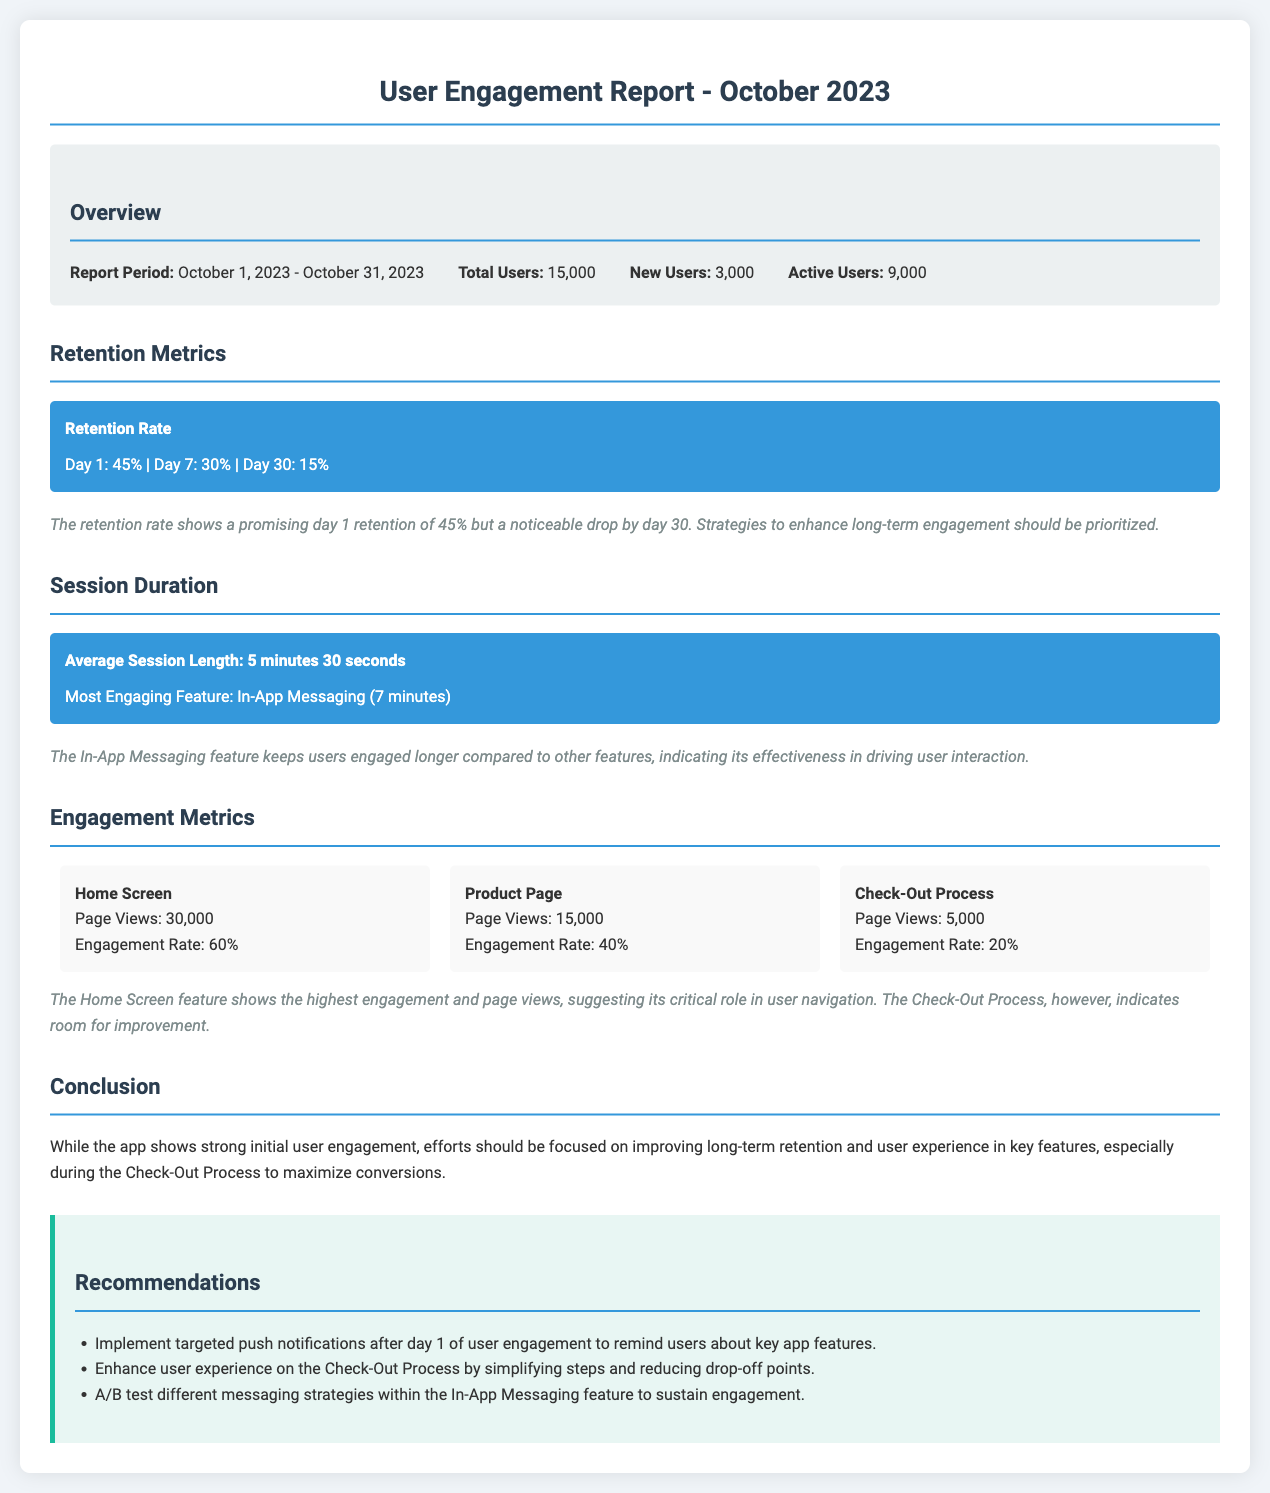What is the report period? The report period is defined at the beginning of the document, covering the span from October 1, 2023, to October 31, 2023.
Answer: October 1, 2023 - October 31, 2023 How many total users were there? The total users are mentioned in the overview section, detailing the specific count.
Answer: 15,000 What was the Day 30 retention rate? The retention metrics section provides the retention rates for specific days, including Day 30.
Answer: 15% What is the average session length? The average session length is specified in the session duration section, indicating user engagement time.
Answer: 5 minutes 30 seconds Which feature has the highest engagement rate? Engagement metrics detail various features and their corresponding engagement rates, highlighting the most engaging one.
Answer: Home Screen How does the Day 1 retention compare to Day 30? A comparison can be drawn from the retention metrics showcasing the drop in user retention from Day 1 to Day 30.
Answer: Significant drop What is a key recommendation regarding the Check-Out Process? The recommendations section emphasizes the importance of optimizing the Check-Out Process, addressing user experience.
Answer: Simplifying steps What was the engagement rate for the Product Page? The engagement metrics provide specific engagement rates for different features, including the Product Page.
Answer: 40% What section provides insights on the feature with most engagement? The engagement metrics section discusses various features, detailing their engagement statistics, including the most engaging feature.
Answer: Engagement Metrics 